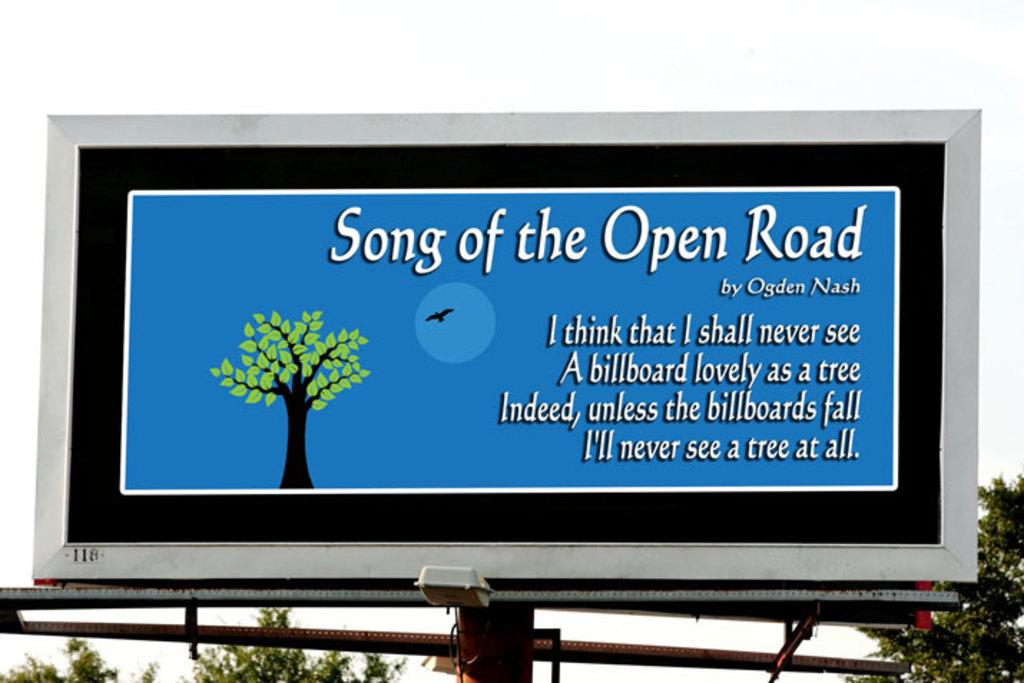<image>
Render a clear and concise summary of the photo. A billboard citing the lyrics of song of the open road. 